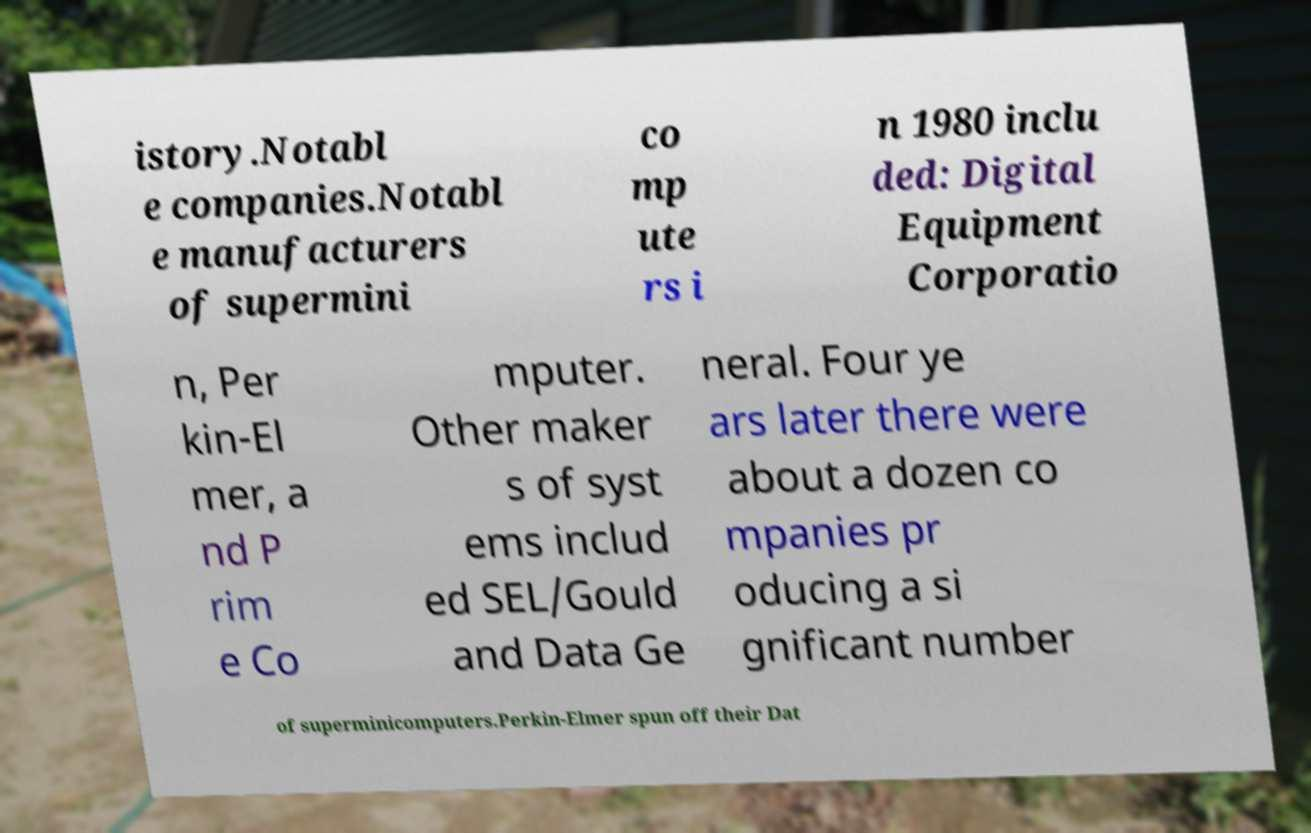For documentation purposes, I need the text within this image transcribed. Could you provide that? istory.Notabl e companies.Notabl e manufacturers of supermini co mp ute rs i n 1980 inclu ded: Digital Equipment Corporatio n, Per kin-El mer, a nd P rim e Co mputer. Other maker s of syst ems includ ed SEL/Gould and Data Ge neral. Four ye ars later there were about a dozen co mpanies pr oducing a si gnificant number of superminicomputers.Perkin-Elmer spun off their Dat 